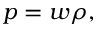Convert formula to latex. <formula><loc_0><loc_0><loc_500><loc_500>p = w \rho ,</formula> 